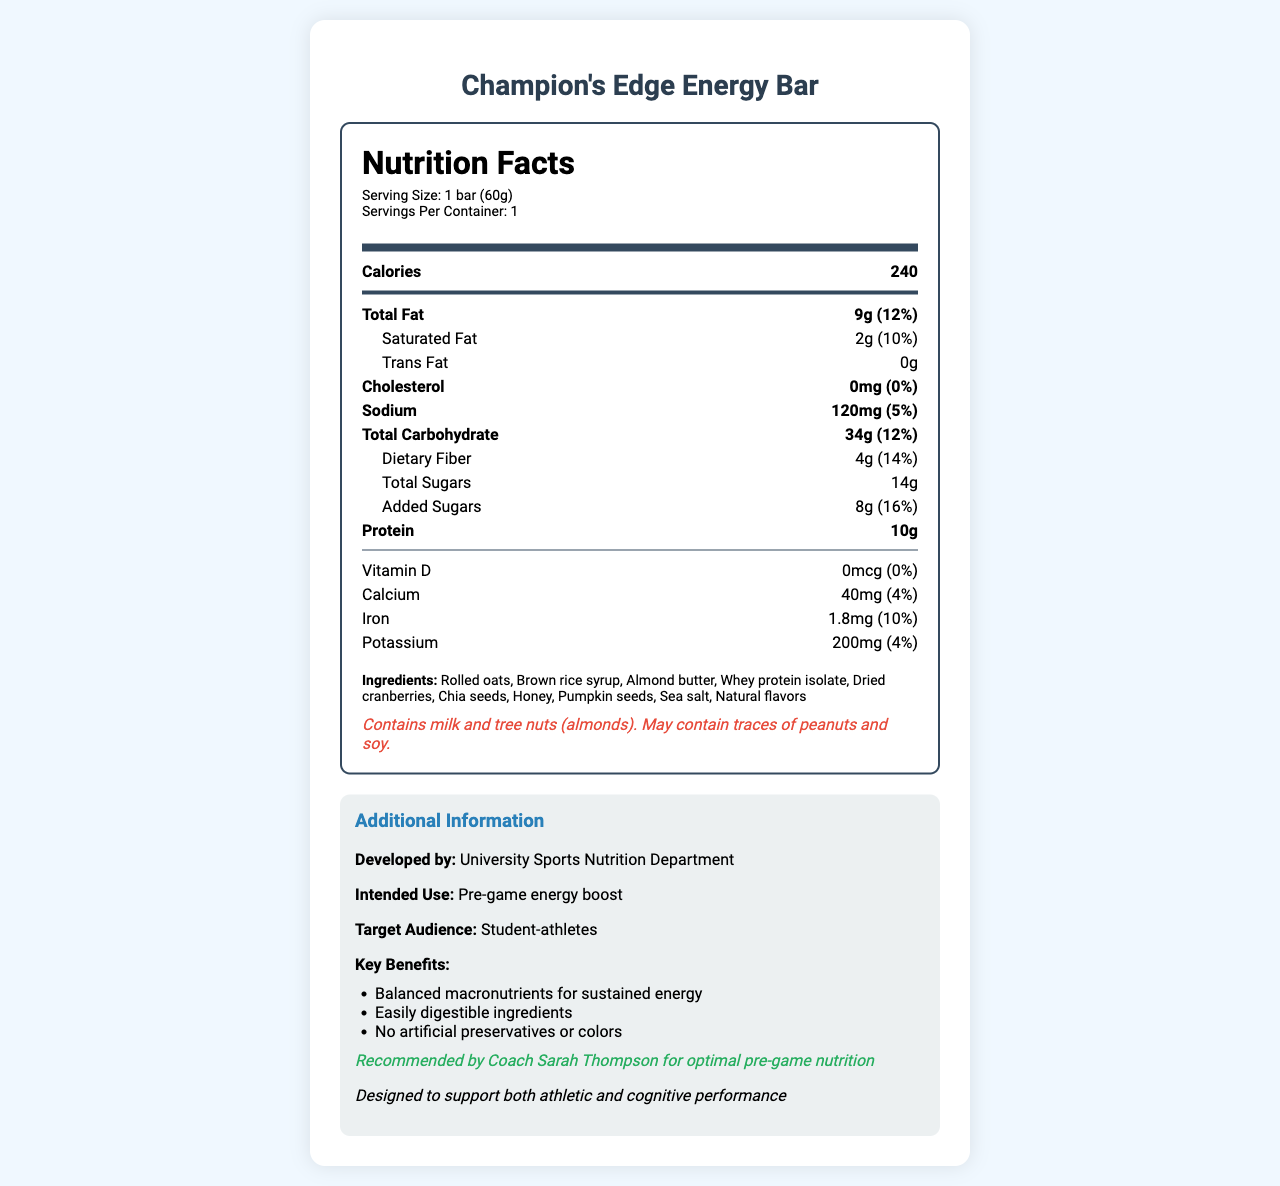what is the product name? The product name is explicitly mentioned at the top of the document in the title and within the body of the document.
Answer: Champion's Edge Energy Bar how many calories are in one serving? The number of calories per serving is listed under the "Calories" section.
Answer: 240 what is the serving size? The serving size is mentioned below the nutrition title as "Serving Size: 1 bar (60g)".
Answer: 1 bar (60g) what is the main source of protein in the Champion's Edge Energy Bar? The ingredient list includes "Whey protein isolate," which is the main source of protein in the energy bar.
Answer: Whey protein isolate what percentage of the daily value of dietary fiber does one bar provide? The daily value percentage for dietary fiber is listed as 14% next to the amount of fiber.
Answer: 14% what are the primary ingredients in the Champion's Edge Energy Bar? A. Whey protein isolate, Rolled oats, Almond butter B. Rolled oats, Brown rice syrup, Almond butter C. Dried cranberries, Chia seeds, Sea salt The primary ingredients include "Rolled oats," "Brown rice syrup," and "Almond butter" as listed in the ingredient section.
Answer: B which type of fat is absent in the Champion's Edge Energy Bar? A. Saturated fat B. Trans fat C. Total fat The document states that the amount of trans fat is "0g."
Answer: B does the energy bar contain any allergens? The allergen information section specifies that the bar contains milk and tree nuts (almonds) and may contain traces of peanuts and soy.
Answer: Yes who recommended the Champion's Edge Energy Bar? The additional information section mentions that the bar is recommended by Coach Sarah Thompson.
Answer: Coach Sarah Thompson summarize the key benefits of the Champion's Edge Energy Bar. The key benefits are listed under the additional information section, which highlights these specific points.
Answer: Balanced macronutrients for sustained energy, Easily digestible ingredients, No artificial preservatives or colors what is the intended use of the Champion's Edge Energy Bar? The intended use is stated in the additional information section as a "Pre-game energy boost."
Answer: Pre-game energy boost can you determine how much vitamin C is in the energy bar? The nutrition label doesn't mention vitamin C content.
Answer: Not enough information what is the daily value percentage of sodium in one serving of the energy bar? The daily value percentage for sodium is mentioned as 5% next to the amount of sodium.
Answer: 5% what is the amount of added sugars in the Champion's Edge Energy Bar? The document specifies that there are 8g of added sugars in the energy bar.
Answer: 8g for whom is the Champion's Edge Energy Bar primarily developed? A. Professional athletes B. Gym-goers C. Student-athletes The target audience specified in the additional information section is "Student-athletes".
Answer: C 